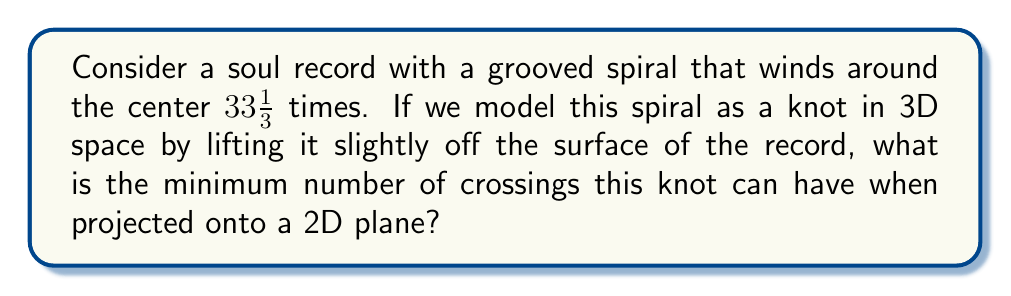Can you solve this math problem? To solve this problem, we'll follow these steps:

1) First, we need to understand that the grooved spiral on a record can be modeled as a torus knot. Specifically, it's a $(p,q)$-torus knot, where $p$ represents the number of times the spiral winds around the center of the record, and $q=1$ because it passes through the "hole" of the torus once per revolution.

2) In this case, $p = 33\frac{1}{3}$, which we can express as the fraction $\frac{100}{3}$.

3) For a $(p,1)$-torus knot, the minimum number of crossings is given by the formula:

   $$\text{min crossings} = p - 1$$

4) Substituting our value for $p$:

   $$\text{min crossings} = \frac{100}{3} - 1 = \frac{100}{3} - \frac{3}{3} = \frac{97}{3}$$

5) Since we're dealing with physical crossings, we need to round this up to the nearest integer.

6) $\frac{97}{3} \approx 32.33$, which rounds up to 33.

Therefore, the minimum number of crossings for this soul record's grooved spiral, when modeled as a knot and projected onto a 2D plane, is 33.
Answer: 33 